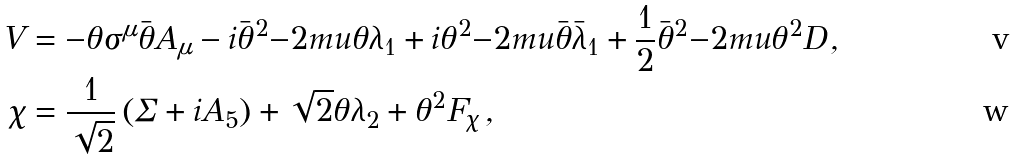Convert formula to latex. <formula><loc_0><loc_0><loc_500><loc_500>V & = - \theta \sigma ^ { \mu } \bar { \theta } A _ { \mu } - i \bar { \theta } ^ { 2 } { - 2 m u } \theta \lambda _ { 1 } + i \theta ^ { 2 } { - 2 m u } \bar { \theta } \bar { \lambda } _ { 1 } + \frac { 1 } { 2 } \bar { \theta } ^ { 2 } { - 2 m u } \theta ^ { 2 } D \, , \\ \chi & = \frac { 1 } { \sqrt { 2 } } \left ( \Sigma + i A _ { 5 } \right ) + \sqrt { 2 } \theta \lambda _ { 2 } + \theta ^ { 2 } F _ { \chi } \, ,</formula> 